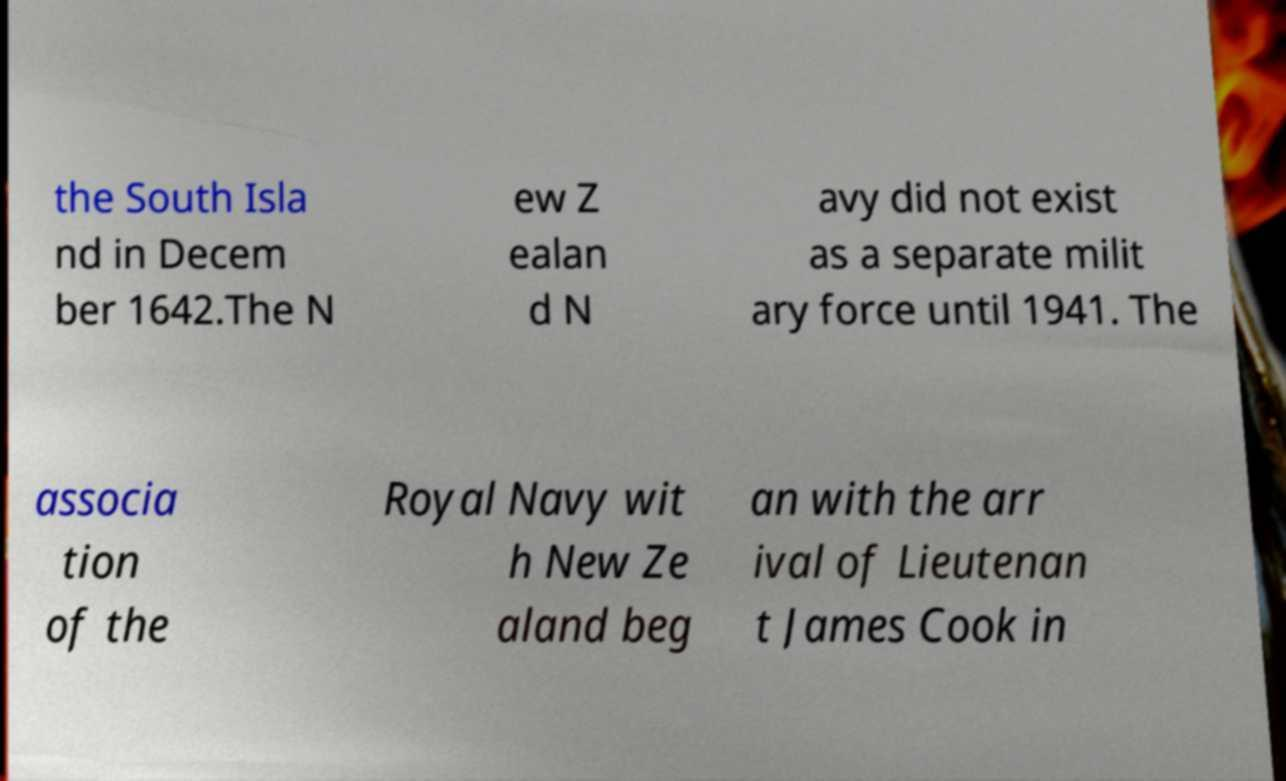Please identify and transcribe the text found in this image. the South Isla nd in Decem ber 1642.The N ew Z ealan d N avy did not exist as a separate milit ary force until 1941. The associa tion of the Royal Navy wit h New Ze aland beg an with the arr ival of Lieutenan t James Cook in 